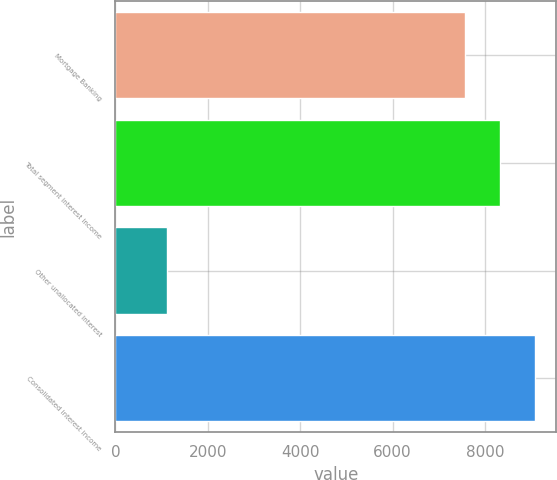Convert chart to OTSL. <chart><loc_0><loc_0><loc_500><loc_500><bar_chart><fcel>Mortgage Banking<fcel>Total segment interest income<fcel>Other unallocated interest<fcel>Consolidated interest income<nl><fcel>7569<fcel>8325.9<fcel>1111<fcel>9082.8<nl></chart> 